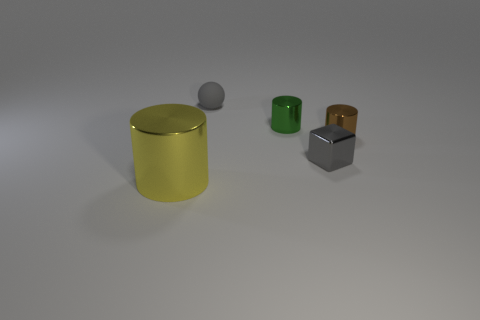Subtract all tiny shiny cylinders. How many cylinders are left? 1 Add 4 tiny green cylinders. How many objects exist? 9 Subtract all yellow cylinders. How many cylinders are left? 2 Subtract all yellow balls. Subtract all green cylinders. How many balls are left? 1 Subtract all gray spheres. How many red cubes are left? 0 Subtract all tiny gray metal objects. Subtract all small green shiny objects. How many objects are left? 3 Add 2 big cylinders. How many big cylinders are left? 3 Add 3 gray spheres. How many gray spheres exist? 4 Subtract 0 gray cylinders. How many objects are left? 5 Subtract all spheres. How many objects are left? 4 